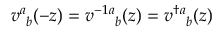Convert formula to latex. <formula><loc_0><loc_0><loc_500><loc_500>v _ { b } ^ { a } ( - z ) = v ^ { - 1 _ { b } ^ { a } ( z ) = v ^ { \dagger _ { b } ^ { a } ( z )</formula> 